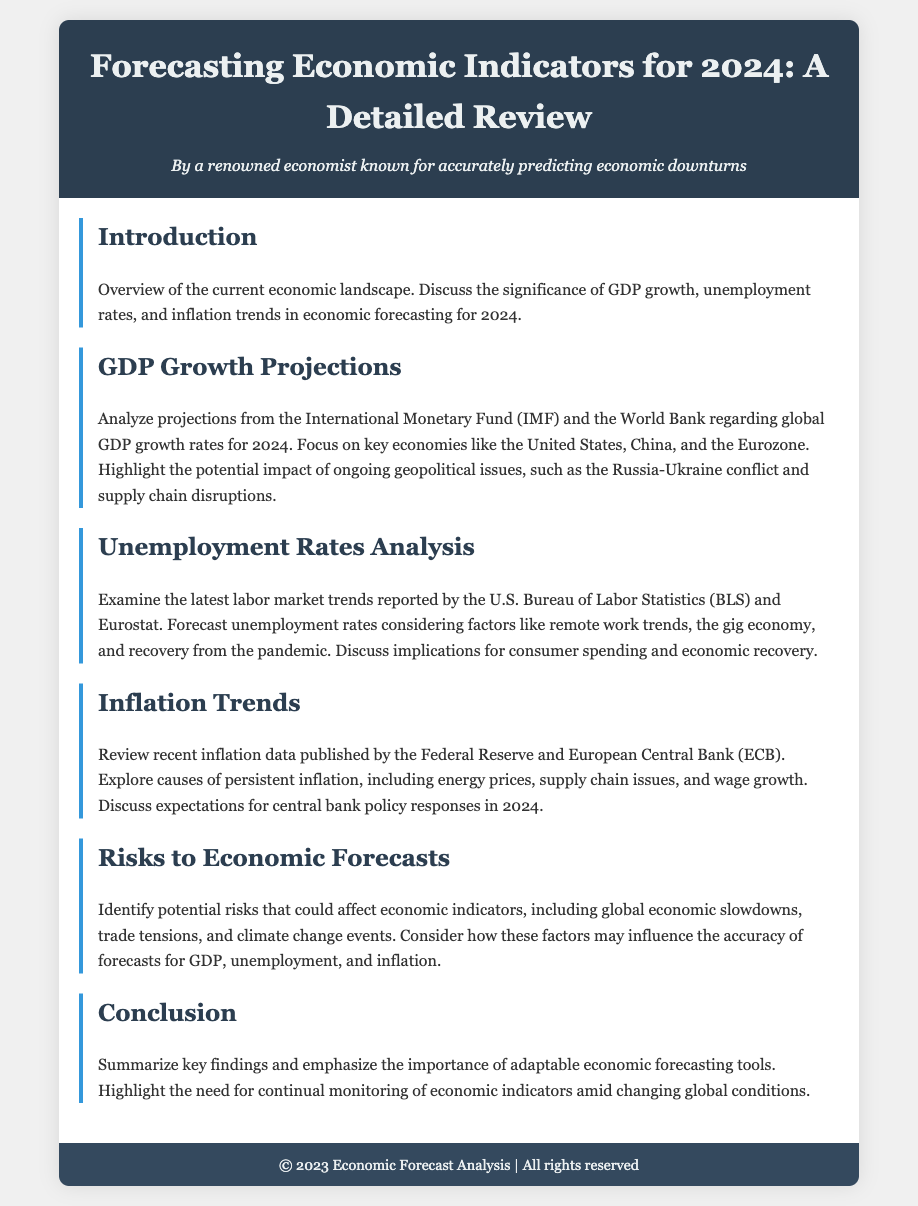What is discussed in the introduction? The introduction provides an overview of the current economic landscape and the significance of GDP growth, unemployment rates, and inflation trends in economic forecasting for 2024.
Answer: Overview of the current economic landscape What organizations' projections are analyzed for GDP growth? The agenda highlights the International Monetary Fund (IMF) and the World Bank regarding global GDP growth rates for 2024.
Answer: IMF and World Bank What are the key economies focused on in GDP growth projections? The document specifically mentions the United States, China, and the Eurozone as key economies in GDP growth projections.
Answer: United States, China, Eurozone Which data sources are used to analyze unemployment rates? The analysis of unemployment rates references the U.S. Bureau of Labor Statistics (BLS) and Eurostat as the latest labor market trend sources.
Answer: U.S. Bureau of Labor Statistics and Eurostat What are the causes of persistent inflation according to the agenda? The agenda outlines several causes for persistent inflation, including energy prices, supply chain issues, and wage growth.
Answer: Energy prices, supply chain issues, wage growth Which monetary policy makers' recent inflation data is reviewed? The document reviews recent inflation data published by the Federal Reserve and European Central Bank (ECB).
Answer: Federal Reserve and European Central Bank What potential risks are identified that could affect economic forecasts? The agenda identifies risks including global economic slowdowns, trade tensions, and climate change events that could impact economic indicators.
Answer: Global economic slowdowns, trade tensions, climate change events What is emphasized in the conclusion of the document? The conclusion summarizes key findings and emphasizes the importance of adaptable economic forecasting tools and monitoring economic indicators.
Answer: Importance of adaptable economic forecasting tools 